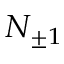<formula> <loc_0><loc_0><loc_500><loc_500>N _ { \pm 1 }</formula> 